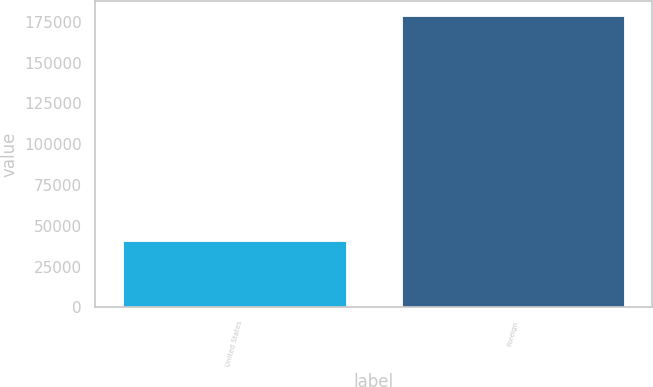Convert chart. <chart><loc_0><loc_0><loc_500><loc_500><bar_chart><fcel>United States<fcel>Foreign<nl><fcel>40434<fcel>178679<nl></chart> 